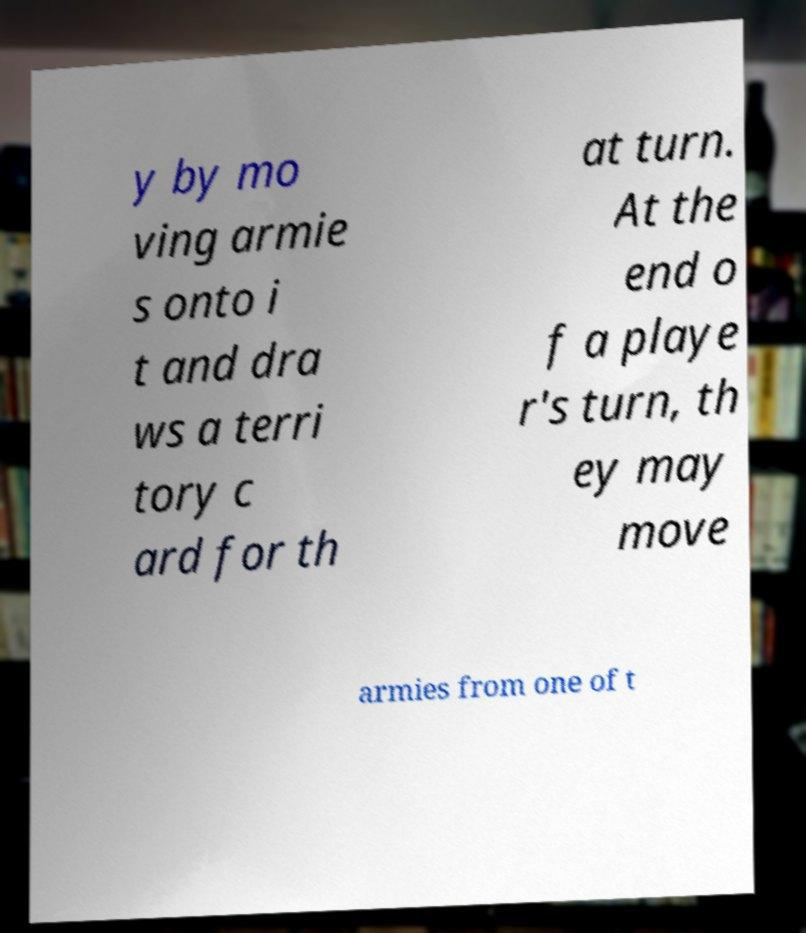Please read and relay the text visible in this image. What does it say? y by mo ving armie s onto i t and dra ws a terri tory c ard for th at turn. At the end o f a playe r's turn, th ey may move armies from one of t 